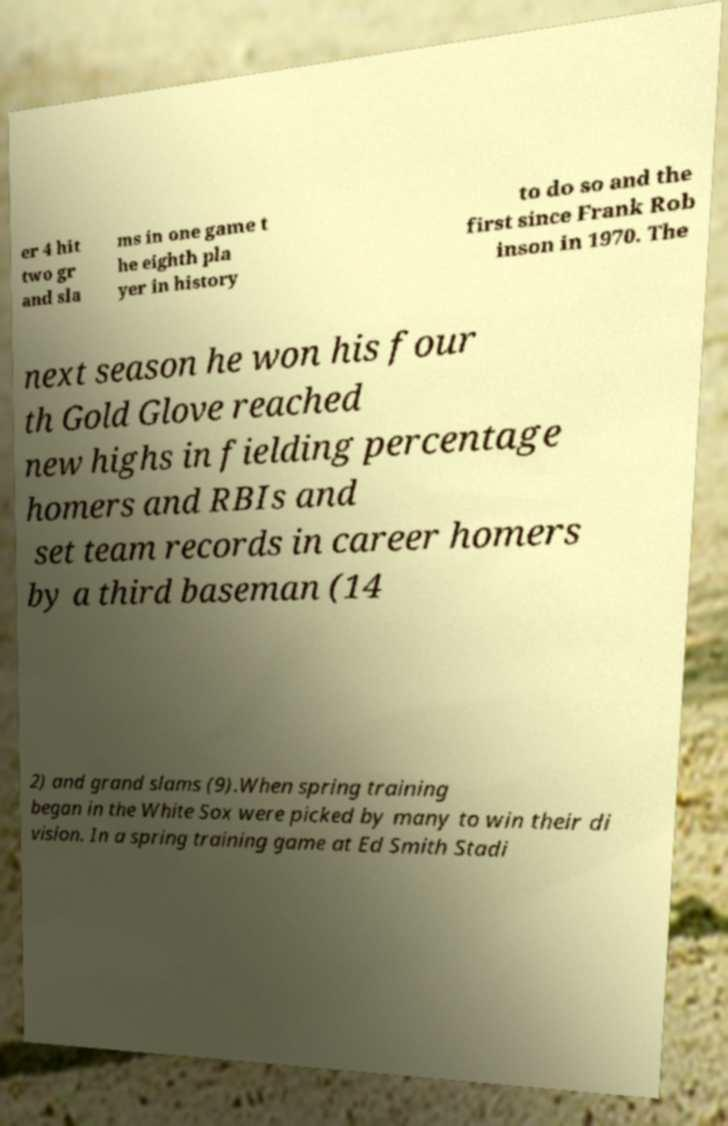I need the written content from this picture converted into text. Can you do that? er 4 hit two gr and sla ms in one game t he eighth pla yer in history to do so and the first since Frank Rob inson in 1970. The next season he won his four th Gold Glove reached new highs in fielding percentage homers and RBIs and set team records in career homers by a third baseman (14 2) and grand slams (9).When spring training began in the White Sox were picked by many to win their di vision. In a spring training game at Ed Smith Stadi 